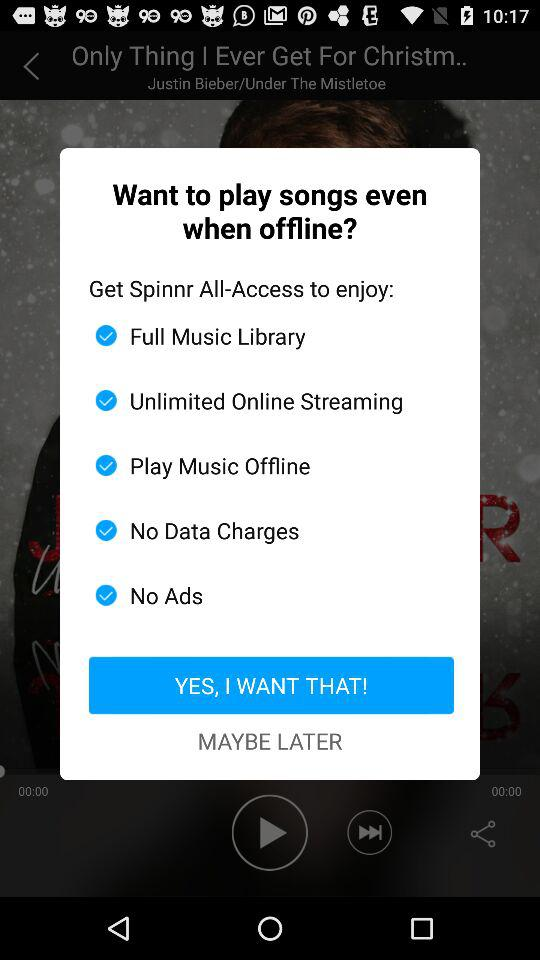What is the singer name? The singer name is Justin Bieber. 